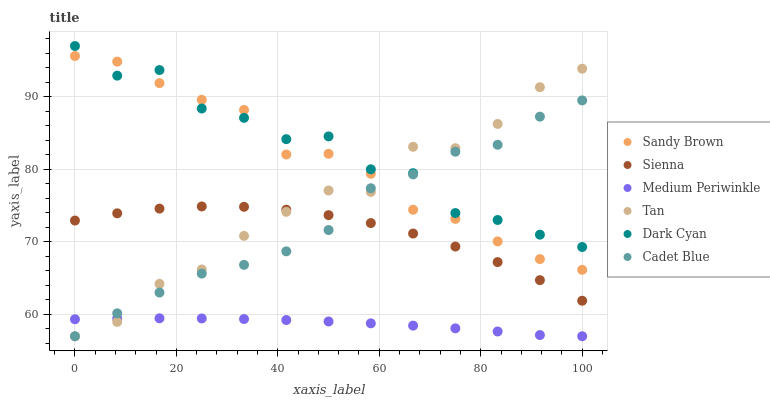Does Medium Periwinkle have the minimum area under the curve?
Answer yes or no. Yes. Does Dark Cyan have the maximum area under the curve?
Answer yes or no. Yes. Does Sienna have the minimum area under the curve?
Answer yes or no. No. Does Sienna have the maximum area under the curve?
Answer yes or no. No. Is Medium Periwinkle the smoothest?
Answer yes or no. Yes. Is Dark Cyan the roughest?
Answer yes or no. Yes. Is Sienna the smoothest?
Answer yes or no. No. Is Sienna the roughest?
Answer yes or no. No. Does Cadet Blue have the lowest value?
Answer yes or no. Yes. Does Sienna have the lowest value?
Answer yes or no. No. Does Dark Cyan have the highest value?
Answer yes or no. Yes. Does Sienna have the highest value?
Answer yes or no. No. Is Sienna less than Dark Cyan?
Answer yes or no. Yes. Is Sienna greater than Medium Periwinkle?
Answer yes or no. Yes. Does Medium Periwinkle intersect Cadet Blue?
Answer yes or no. Yes. Is Medium Periwinkle less than Cadet Blue?
Answer yes or no. No. Is Medium Periwinkle greater than Cadet Blue?
Answer yes or no. No. Does Sienna intersect Dark Cyan?
Answer yes or no. No. 